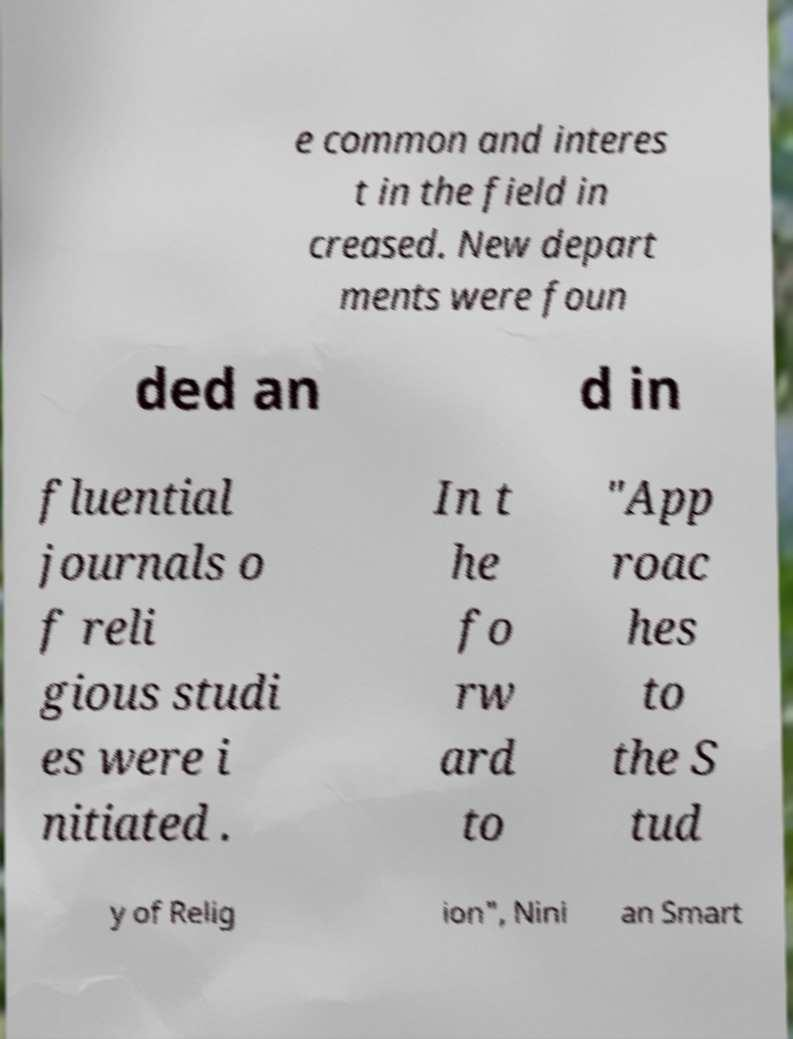For documentation purposes, I need the text within this image transcribed. Could you provide that? e common and interes t in the field in creased. New depart ments were foun ded an d in fluential journals o f reli gious studi es were i nitiated . In t he fo rw ard to "App roac hes to the S tud y of Relig ion", Nini an Smart 